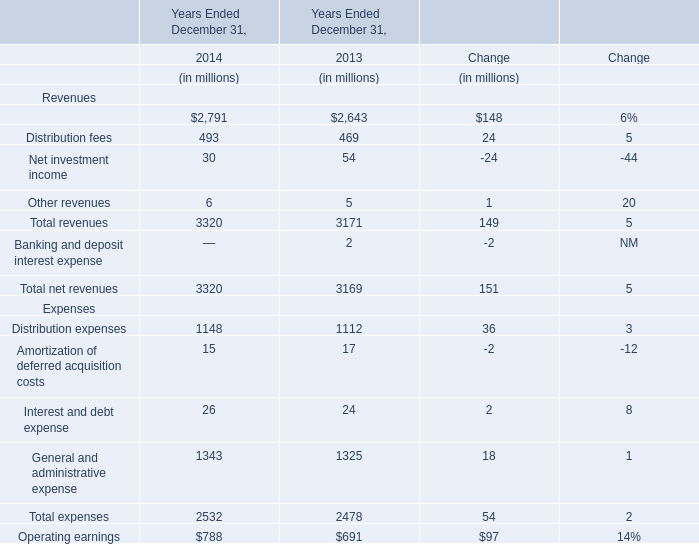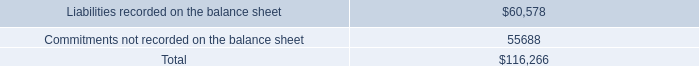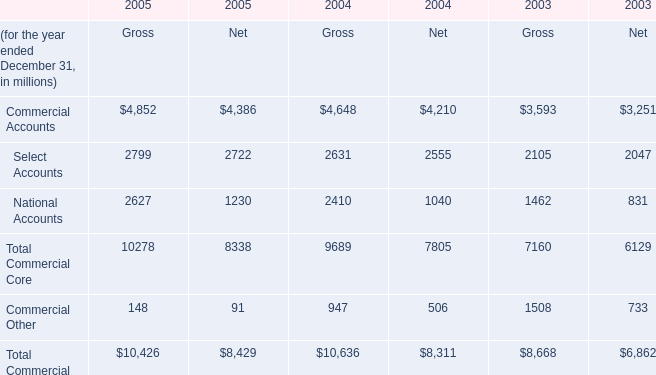What is the total amount of Commercial Accounts of 2004 Net, and Commitments not recorded on the balance sheet ? 
Computations: (4210.0 + 55688.0)
Answer: 59898.0. 